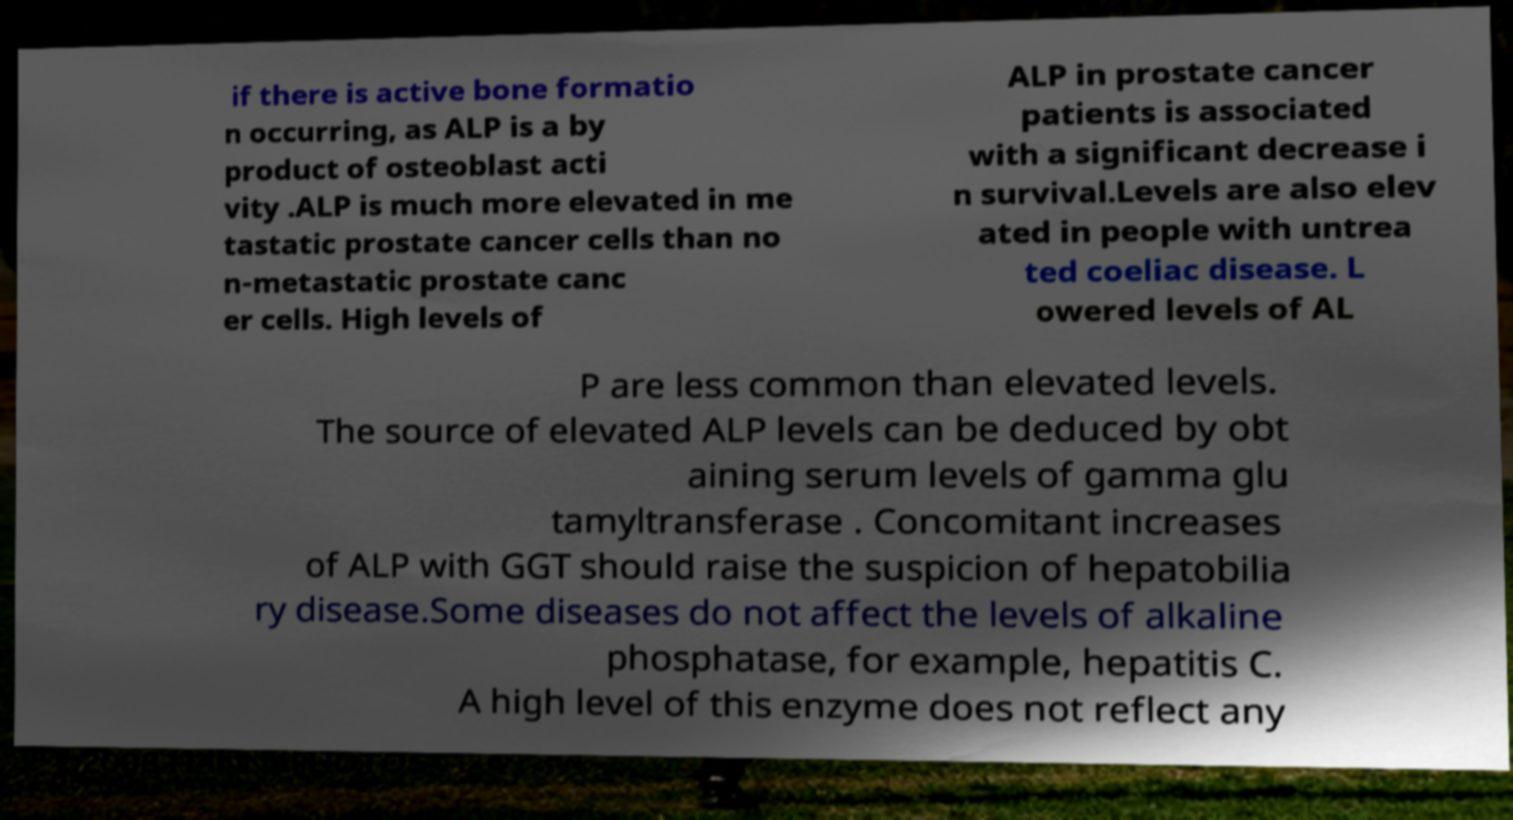I need the written content from this picture converted into text. Can you do that? if there is active bone formatio n occurring, as ALP is a by product of osteoblast acti vity .ALP is much more elevated in me tastatic prostate cancer cells than no n-metastatic prostate canc er cells. High levels of ALP in prostate cancer patients is associated with a significant decrease i n survival.Levels are also elev ated in people with untrea ted coeliac disease. L owered levels of AL P are less common than elevated levels. The source of elevated ALP levels can be deduced by obt aining serum levels of gamma glu tamyltransferase . Concomitant increases of ALP with GGT should raise the suspicion of hepatobilia ry disease.Some diseases do not affect the levels of alkaline phosphatase, for example, hepatitis C. A high level of this enzyme does not reflect any 